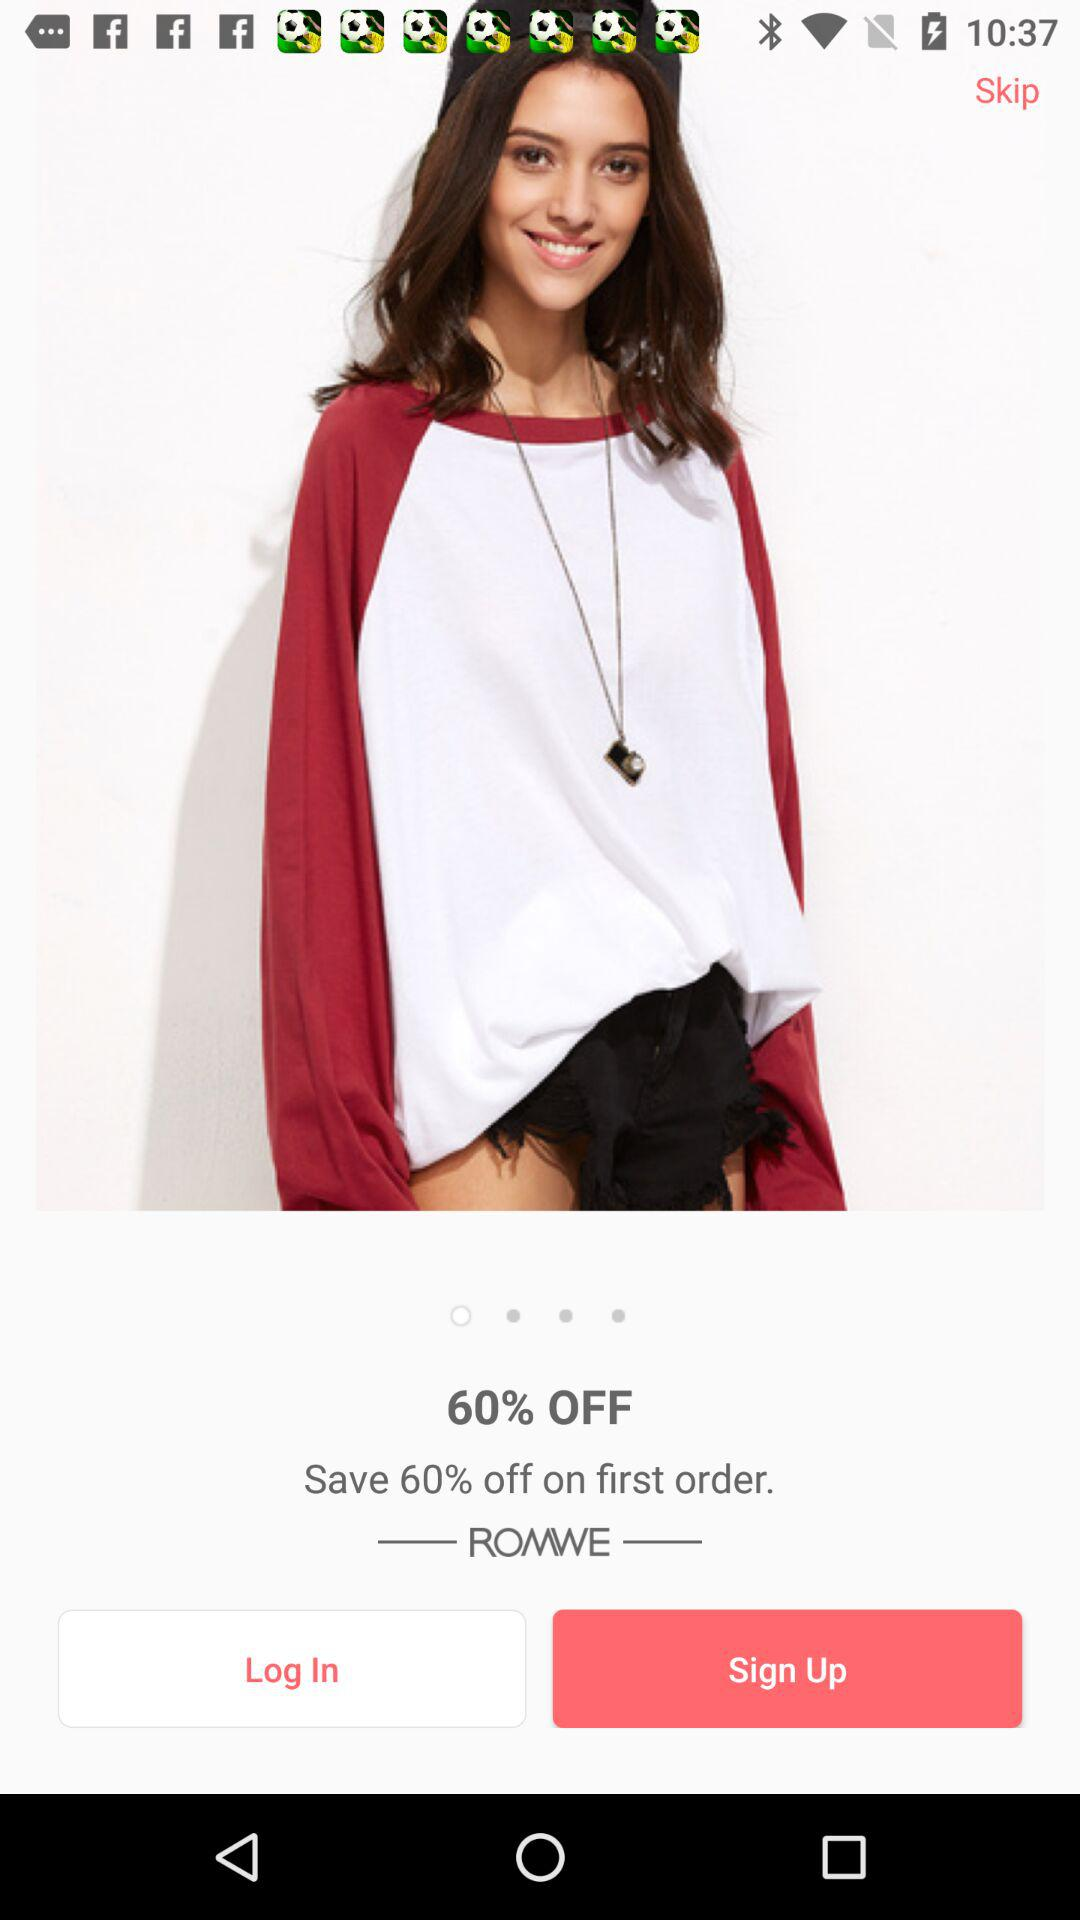How much of a percentage do I save on my first order? You can save 60% on your first order. 